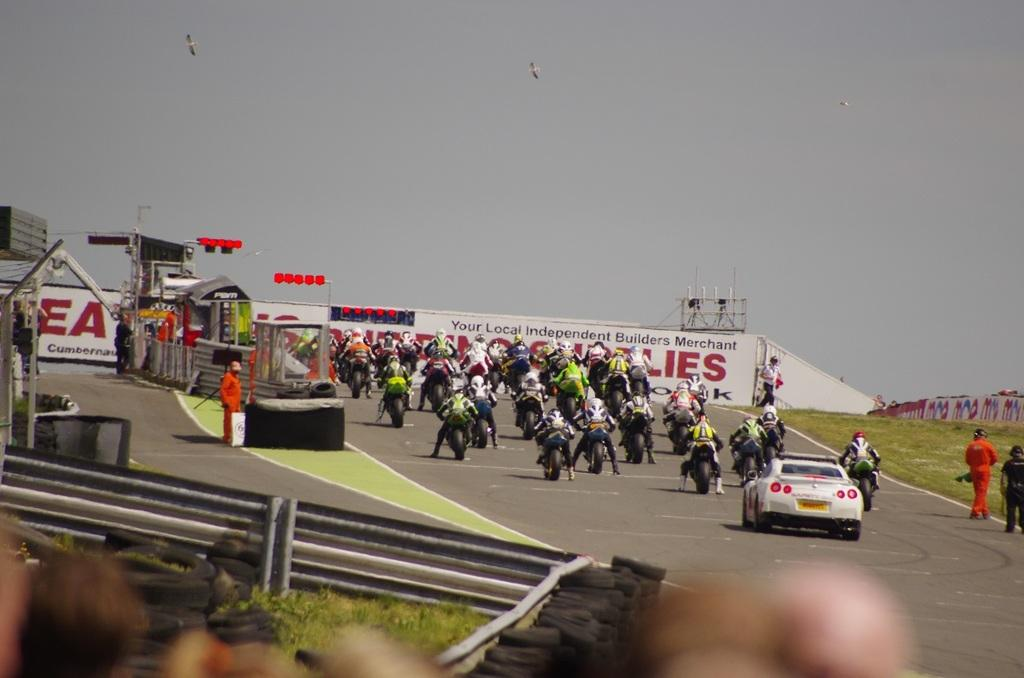<image>
Render a clear and concise summary of the photo. A bunch of people are on motorcycles in front of a wall that says "your local independent builders merchant." 